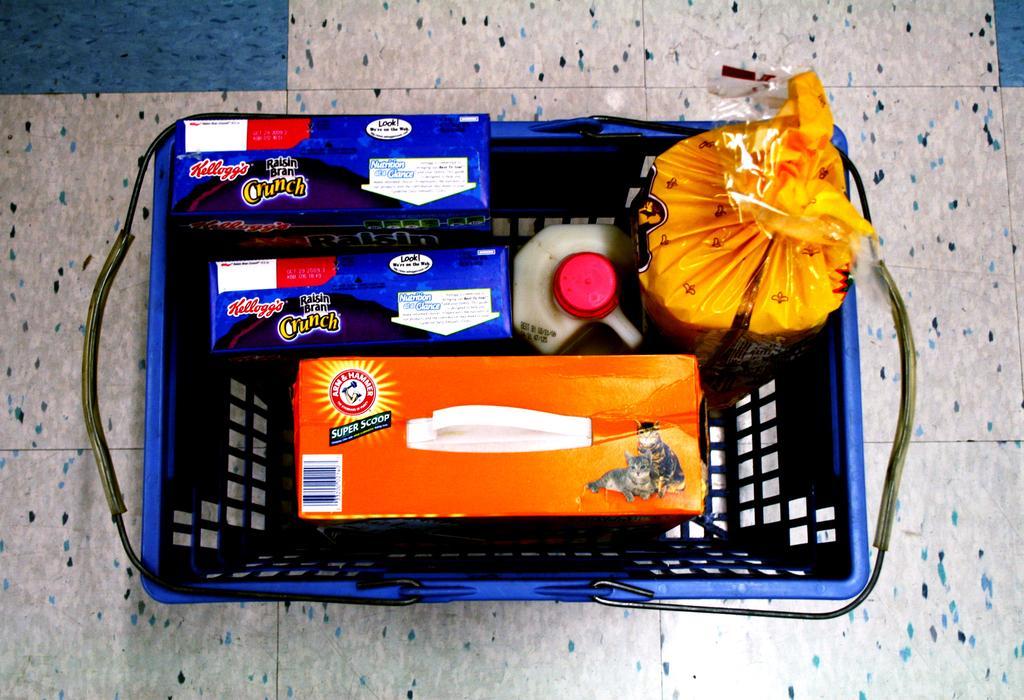Can you describe this image briefly? In this image we can see a basket which is placed on the surface containing some boxes, a container with a lid and a packet. 